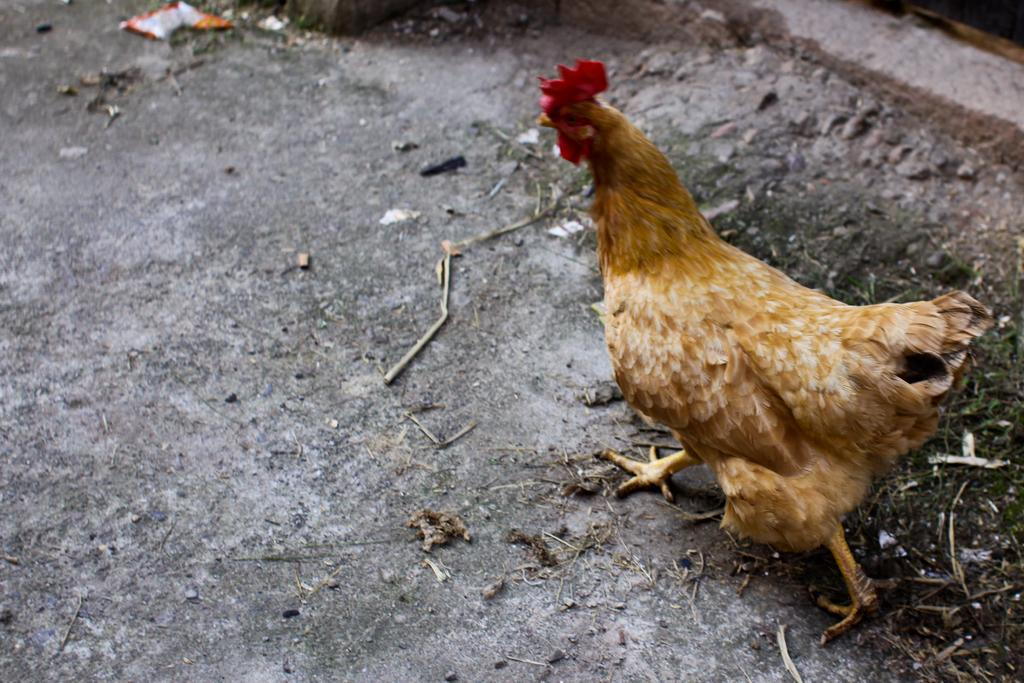What type of animal is present in the image? There is a hen in the image. What else can be seen on the surface in the image? There are dust particles on the surface in the image. Where is the cushion located in the image? There is no cushion present in the image. Is there a rat visible in the image? No, there is no rat visible in the image. 